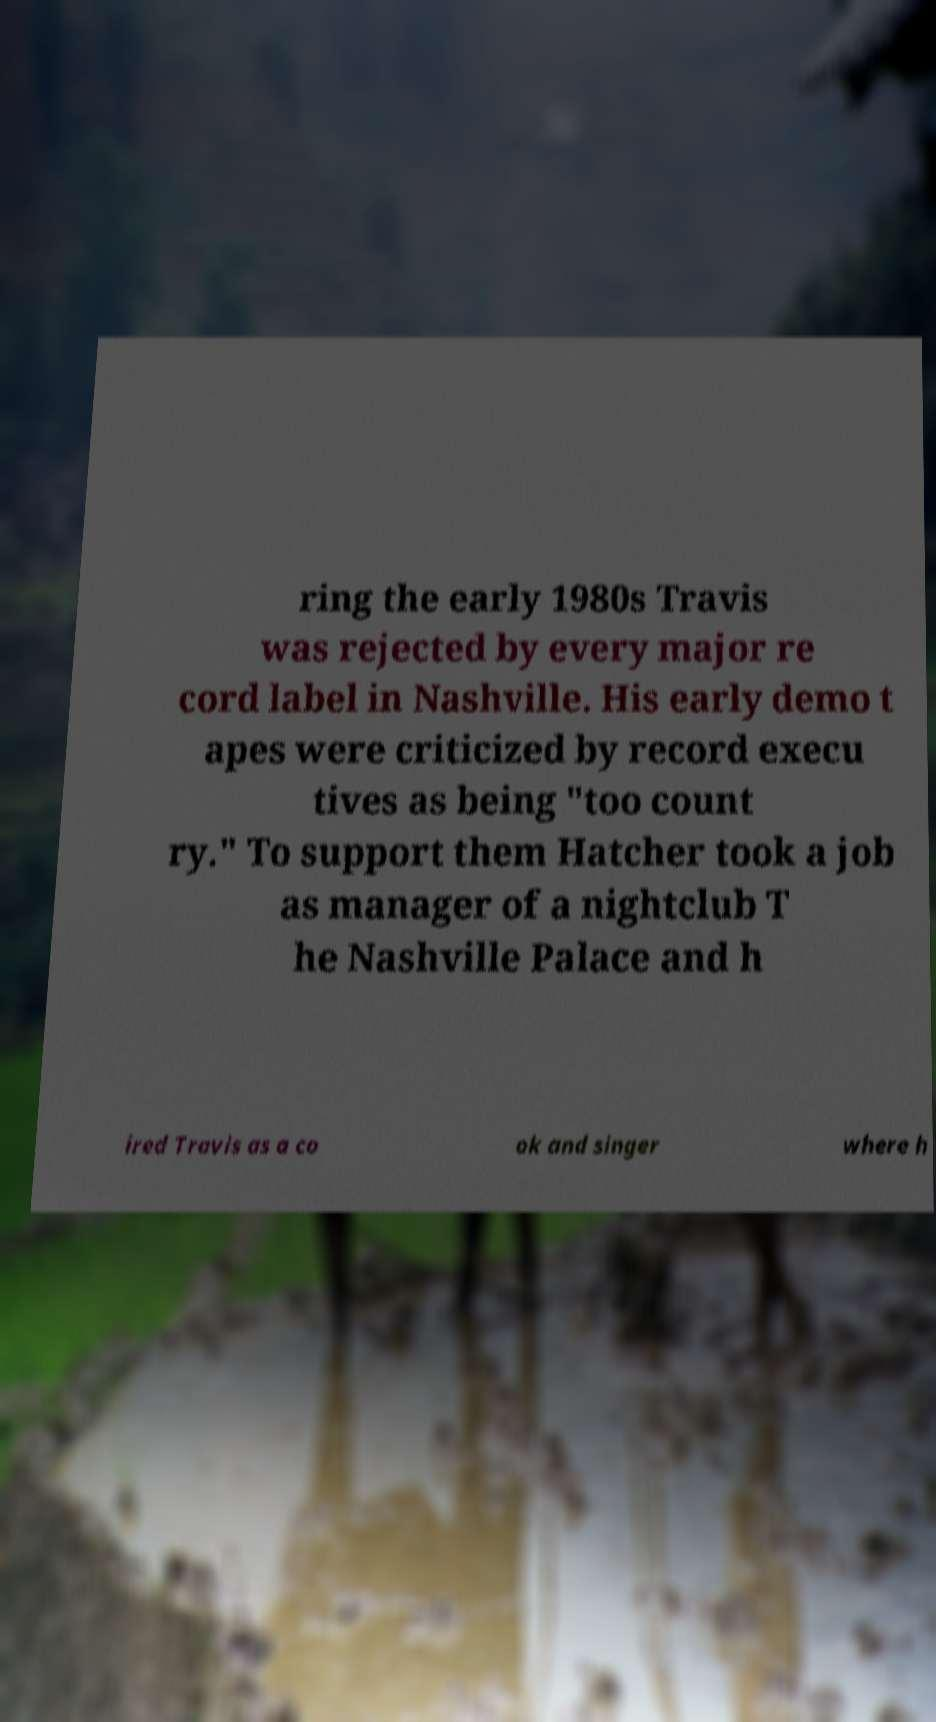For documentation purposes, I need the text within this image transcribed. Could you provide that? ring the early 1980s Travis was rejected by every major re cord label in Nashville. His early demo t apes were criticized by record execu tives as being "too count ry." To support them Hatcher took a job as manager of a nightclub T he Nashville Palace and h ired Travis as a co ok and singer where h 